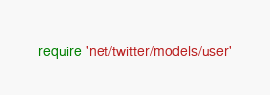<code> <loc_0><loc_0><loc_500><loc_500><_Ruby_>require 'net/twitter/models/user'</code> 